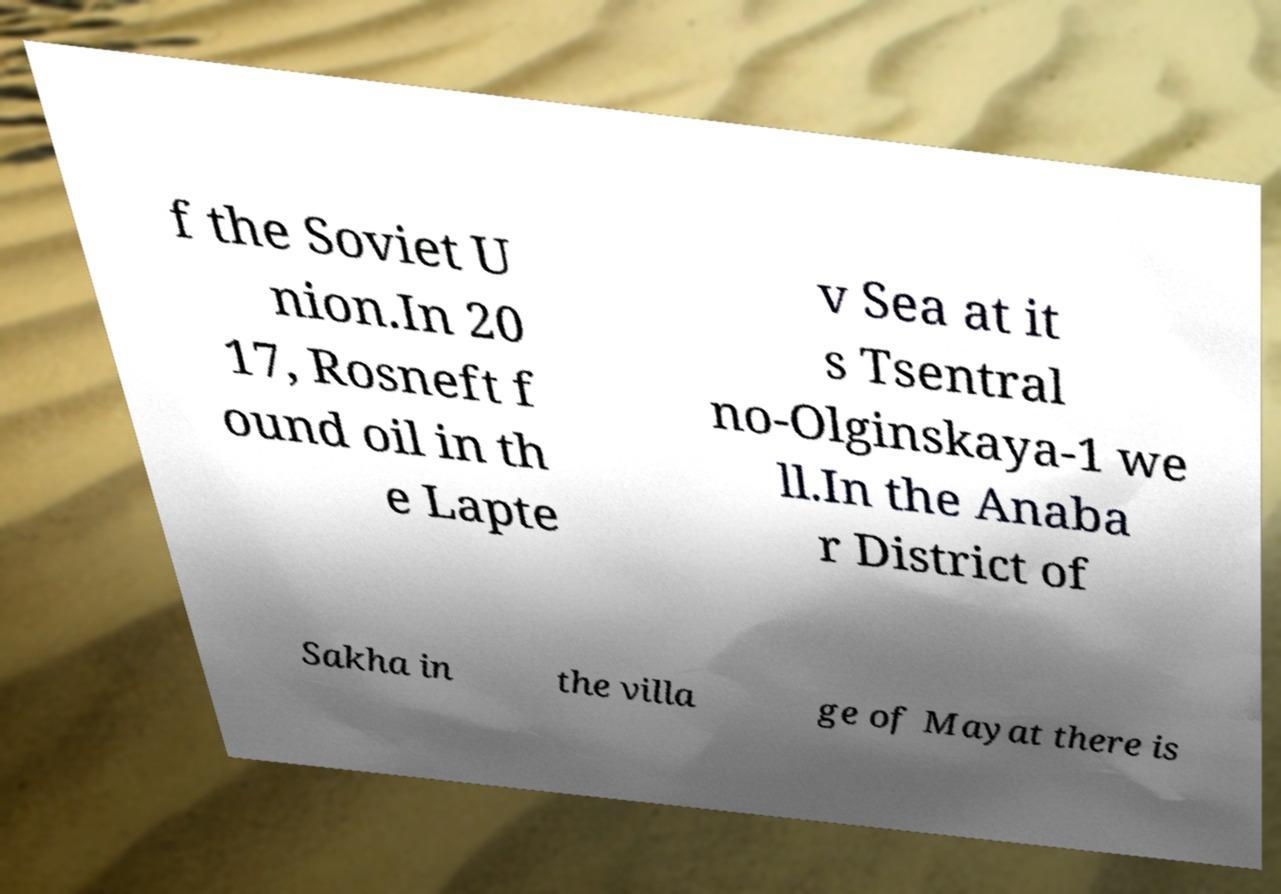Please identify and transcribe the text found in this image. f the Soviet U nion.In 20 17, Rosneft f ound oil in th e Lapte v Sea at it s Tsentral no-Olginskaya-1 we ll.In the Anaba r District of Sakha in the villa ge of Mayat there is 